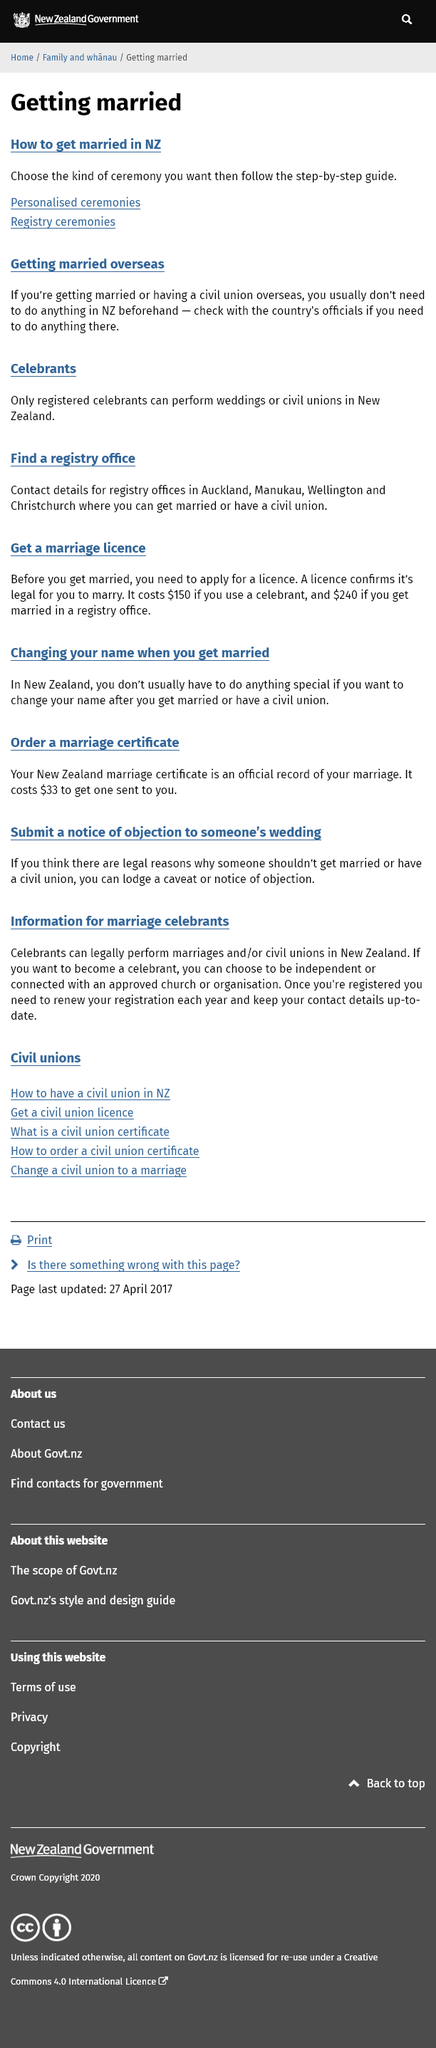Draw attention to some important aspects in this diagram. Yes, the celebrant must be registered. There are ceremony options such as personalized and registry ceremonies. It is generally not necessary to do anything in New Zealand before getting married overseas. 